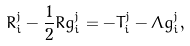<formula> <loc_0><loc_0><loc_500><loc_500>R ^ { j } _ { i } - \frac { 1 } { 2 } R g ^ { j } _ { i } = - T ^ { j } _ { i } - \Lambda g ^ { j } _ { i } ,</formula> 